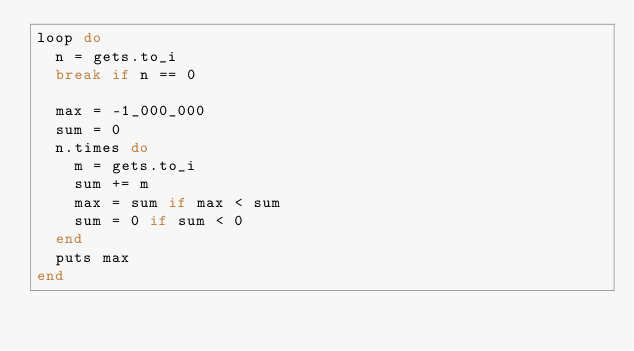Convert code to text. <code><loc_0><loc_0><loc_500><loc_500><_Ruby_>loop do
  n = gets.to_i
  break if n == 0

  max = -1_000_000
  sum = 0
  n.times do
    m = gets.to_i
    sum += m
    max = sum if max < sum
    sum = 0 if sum < 0
  end
  puts max
end</code> 